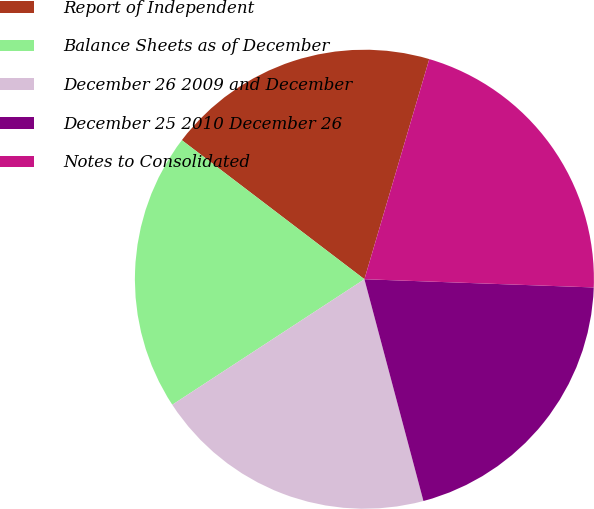Convert chart. <chart><loc_0><loc_0><loc_500><loc_500><pie_chart><fcel>Report of Independent<fcel>Balance Sheets as of December<fcel>December 26 2009 and December<fcel>December 25 2010 December 26<fcel>Notes to Consolidated<nl><fcel>19.2%<fcel>19.57%<fcel>19.93%<fcel>20.29%<fcel>21.01%<nl></chart> 